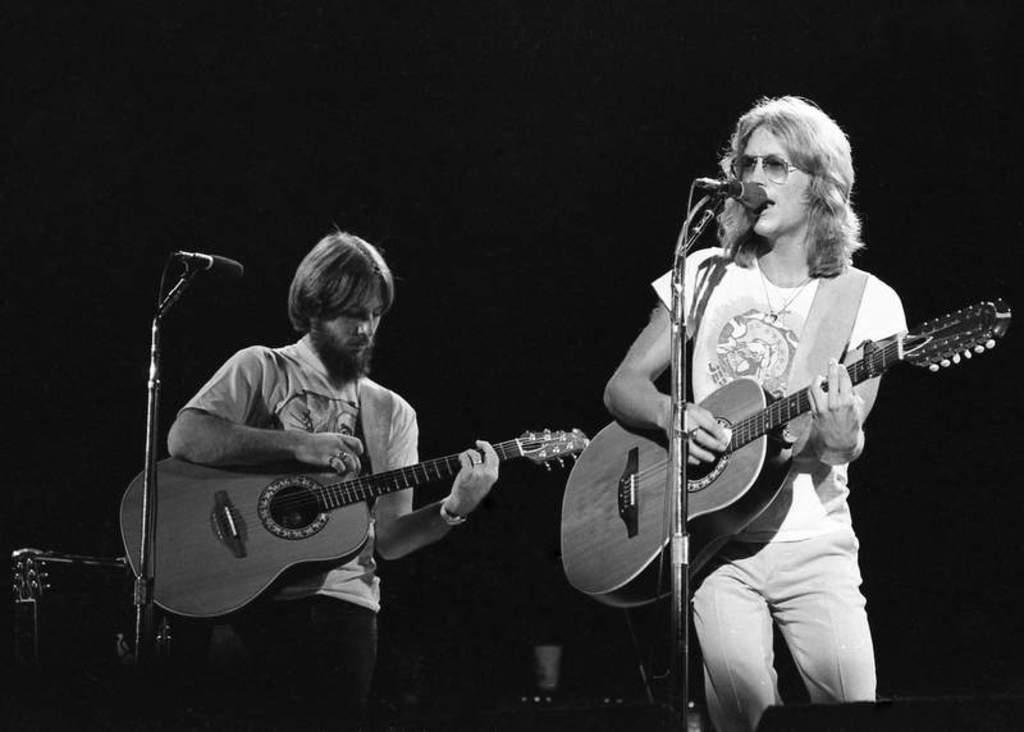In one or two sentences, can you explain what this image depicts? There are two men standing in the picture, holding guitars in their hands. Both of them having a microphones in front of them. 